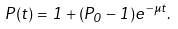<formula> <loc_0><loc_0><loc_500><loc_500>P ( t ) = 1 + ( P _ { 0 } - 1 ) e ^ { - \mu t } .</formula> 